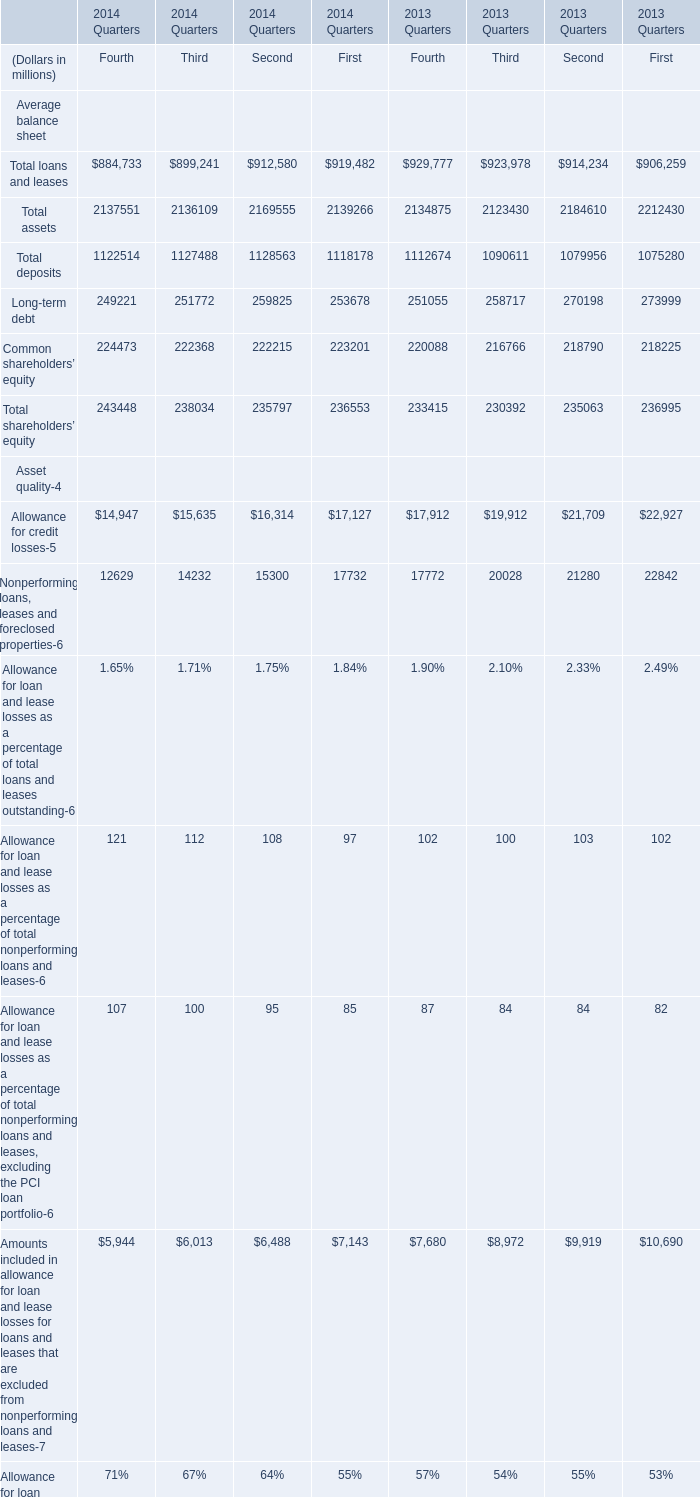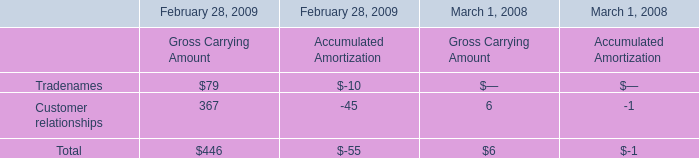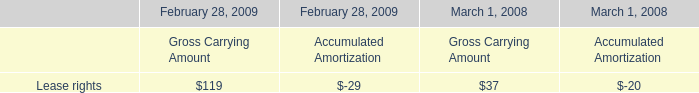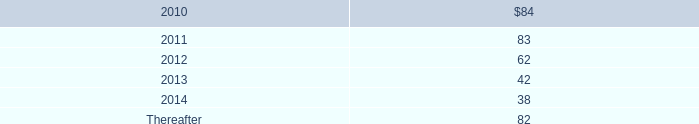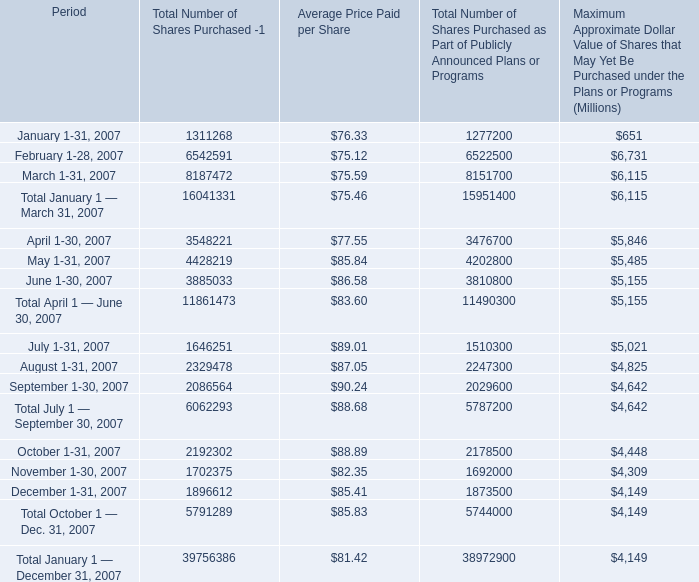What is the difference between the greatest Long-term debt in 2013 and 2014？ (in million) 
Computations: (273999 - 259825)
Answer: 14174.0. 